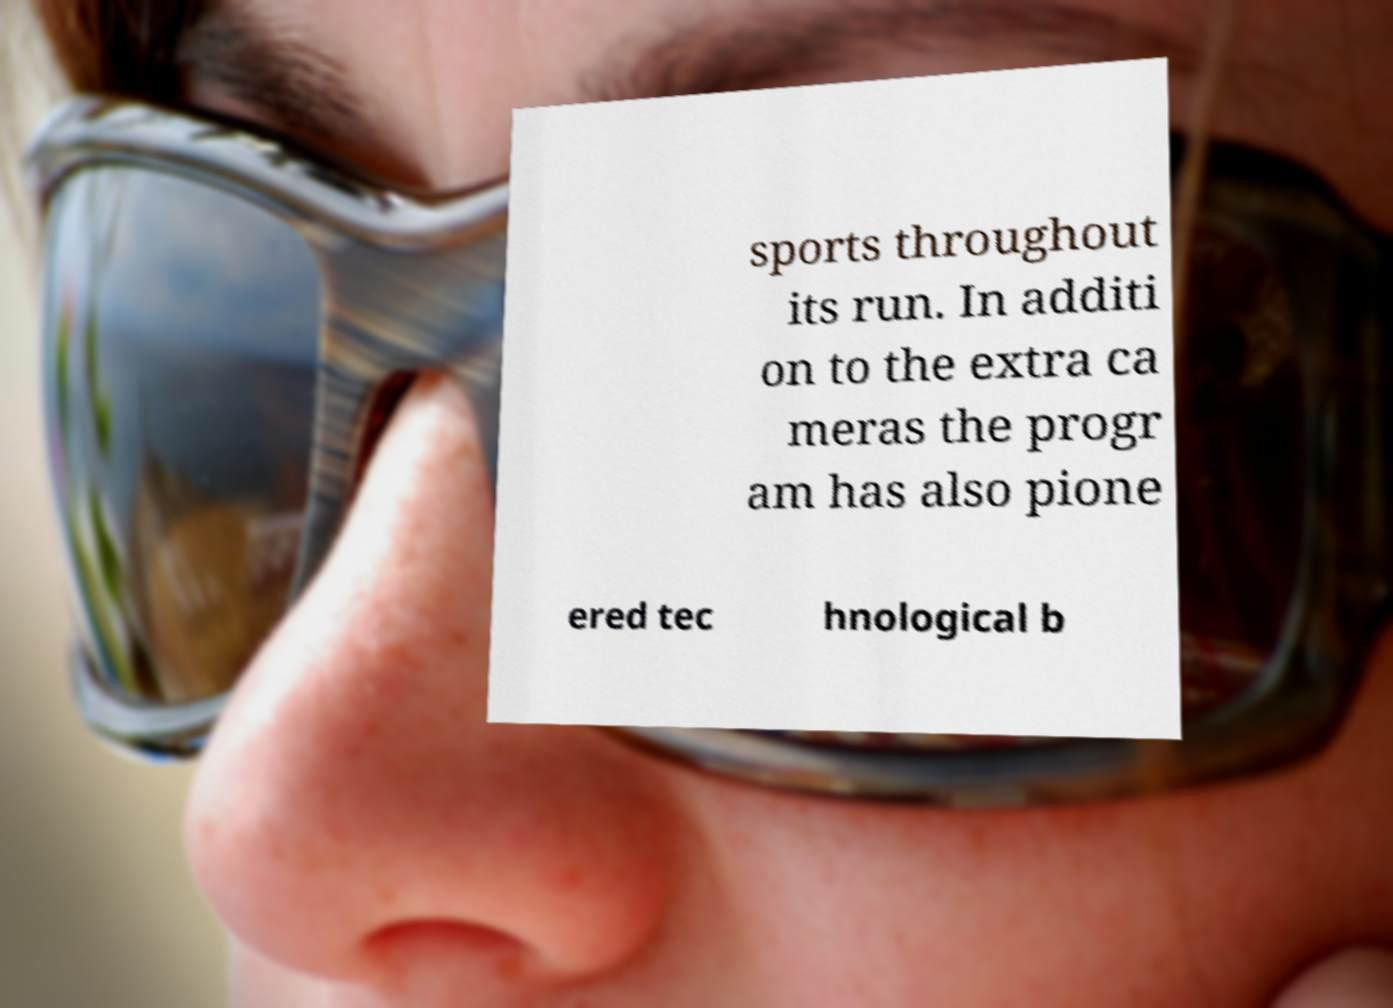Could you extract and type out the text from this image? sports throughout its run. In additi on to the extra ca meras the progr am has also pione ered tec hnological b 